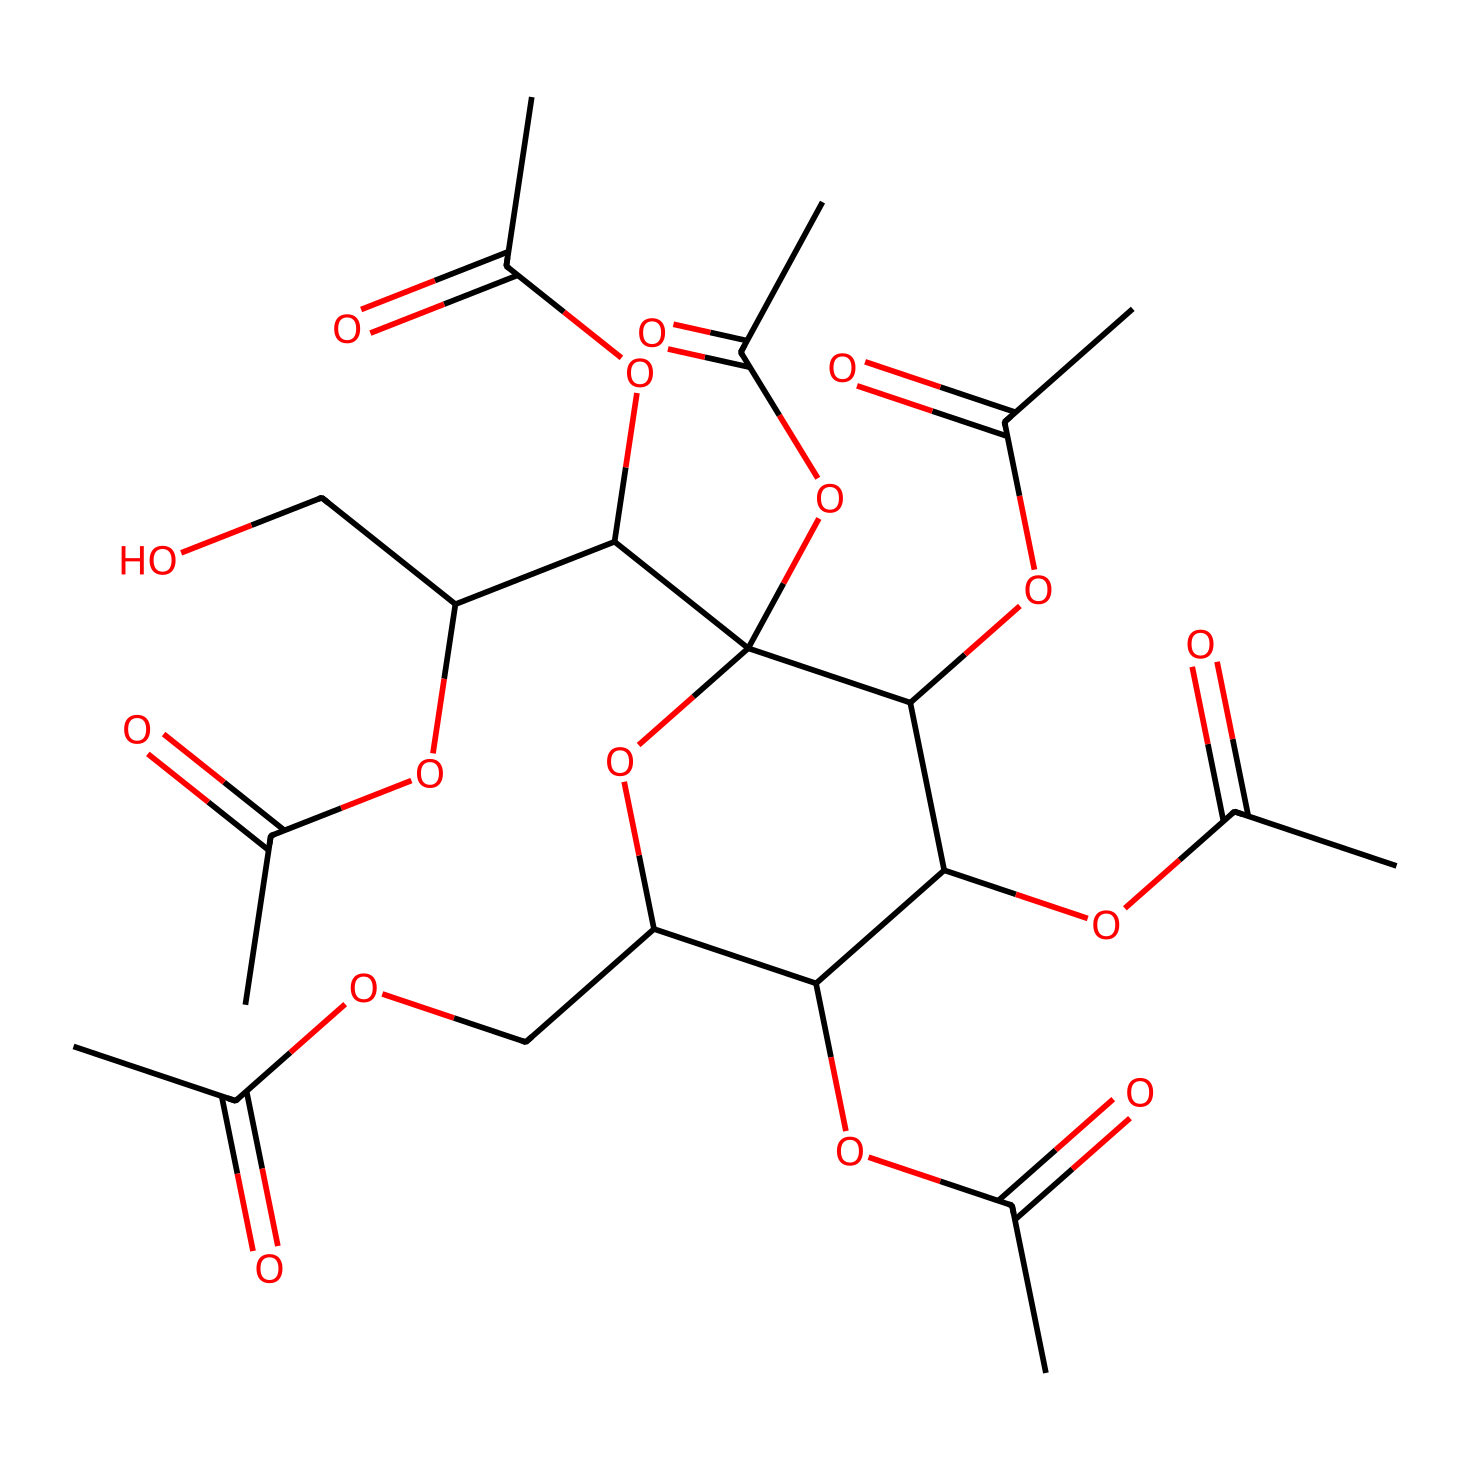how many ester linkages are present in this molecule? In the structure, each ester linkage is identified by the presence of a carbonyl group (C=O) bonded to an alkoxy group (R-O). By examining the molecular structure, there are six carbonyl groups that are part of ester linkages.
Answer: six what is the molecular formula of cellulose acetate? The molecular formula can usually be deduced from the count of the atoms in the chemical structure. By analyzing the atom counts in the provided SMILES, the molecular formula is established as C12H18O9.
Answer: C12H18O9 what type of chemical is cellulose acetate classified as? Cellulose acetate is classified as an ester because it is formed through the reaction of cellulose with acetic anhydride or acetic acid, resulting in the formation of ester linkages.
Answer: ester what functional groups are present in cellulose acetate? The key functional groups in cellulose acetate include ester groups (from the acetate) and hydroxyl groups. Upon examining the structure, these functional groups can be identified clearly, confirming their presence.
Answer: ester and hydroxyl how many acetic acid units are esterified in this molecule? Each acetic acid contributes an acetate group to the overall structure. By detailing the structure, there are six acetate units visible, indicating the number of acetic acid units that are esterified.
Answer: six what is the significance of using cellulose acetate in document preservation? Cellulose acetate is significant in document preservation because it is more stable than regular cellulose, reducing degradation over time and protecting documents from environmental factors.
Answer: stability 